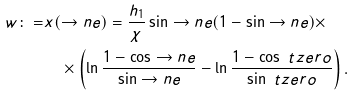<formula> <loc_0><loc_0><loc_500><loc_500>w \colon = & x ( \to n e ) = \frac { h _ { 1 } } { \chi } \sin \to n e ( 1 - \sin \to n e ) \times \\ & \quad \times \left ( \ln \frac { 1 - \cos \to n e } { \sin \to n e } - \ln \frac { 1 - \cos \ t z e r o } { \sin \ t z e r o } \right ) .</formula> 